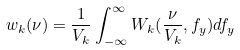Convert formula to latex. <formula><loc_0><loc_0><loc_500><loc_500>w _ { k } ( \nu ) = \frac { 1 } { V _ { k } } \int _ { - \infty } ^ { \infty } W _ { k } ( \frac { \nu } { V _ { k } } , f _ { y } ) d f _ { y }</formula> 